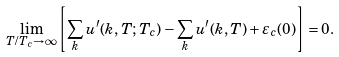Convert formula to latex. <formula><loc_0><loc_0><loc_500><loc_500>\lim _ { T / { T _ { c } } \rightarrow \infty } { \left [ \sum _ { k } u ^ { \prime } ( k , T ; T _ { c } ) - \sum _ { k } u ^ { \prime } ( k , T ) + \varepsilon _ { c } ( 0 ) \right ] } = 0 .</formula> 